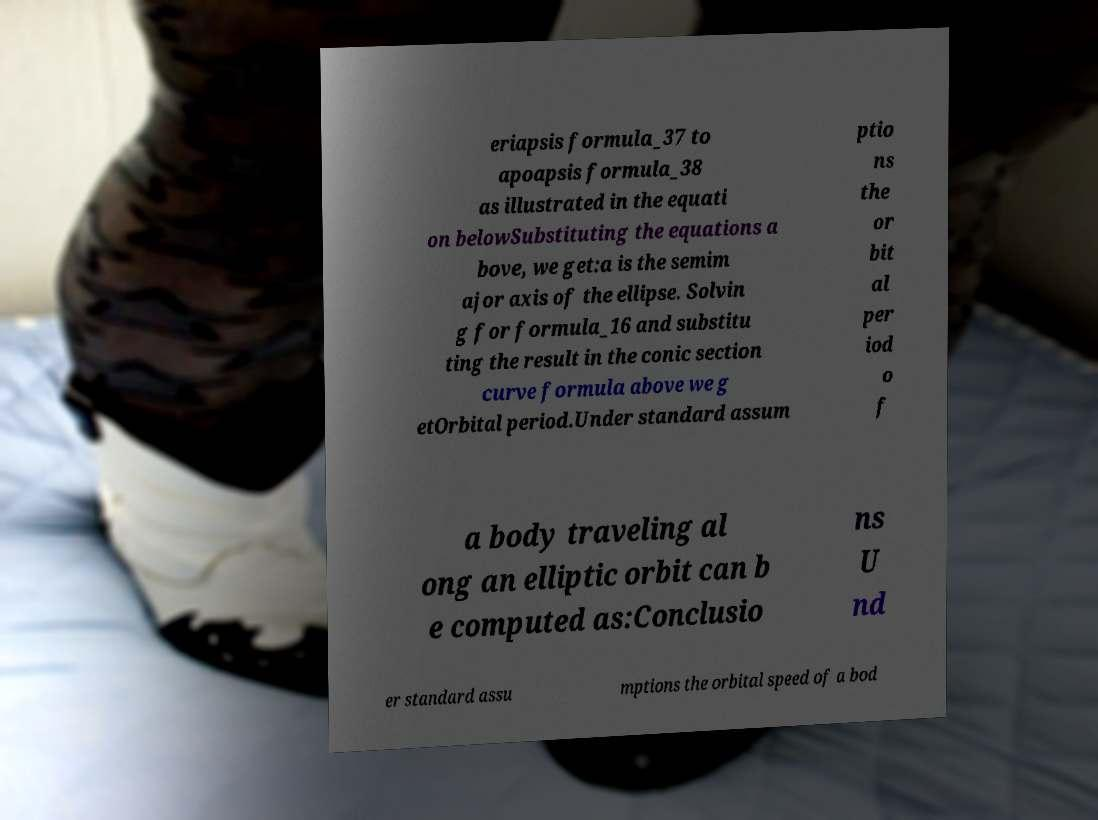Please identify and transcribe the text found in this image. eriapsis formula_37 to apoapsis formula_38 as illustrated in the equati on belowSubstituting the equations a bove, we get:a is the semim ajor axis of the ellipse. Solvin g for formula_16 and substitu ting the result in the conic section curve formula above we g etOrbital period.Under standard assum ptio ns the or bit al per iod o f a body traveling al ong an elliptic orbit can b e computed as:Conclusio ns U nd er standard assu mptions the orbital speed of a bod 